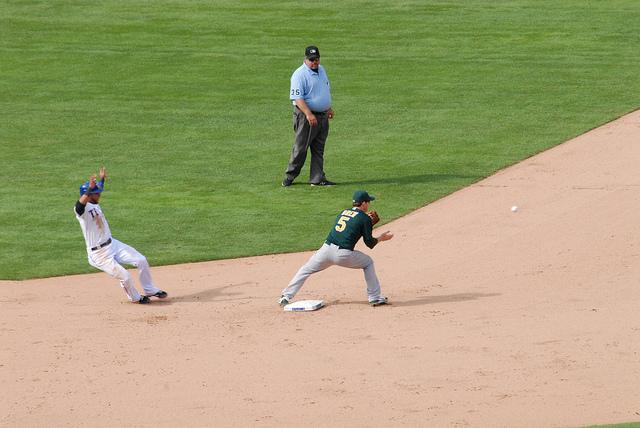Who has number five on his t shirt?
Write a very short answer. Catcher. What game is being played?
Be succinct. Baseball. Will this player be safe?
Concise answer only. Yes. What authority figure is standing near the top of this picture?
Write a very short answer. Umpire. What base is this?
Keep it brief. Second. Who is winning?
Keep it brief. Team in white. Who is this person?
Short answer required. Baseball player. Is the man holding a bat?
Short answer required. No. Is he walking on the green?
Keep it brief. No. What is the second baseman's number?
Write a very short answer. 5. What sport is being played?
Give a very brief answer. Baseball. Is the player running?
Keep it brief. Yes. Is there a ball in this photo?
Keep it brief. Yes. 